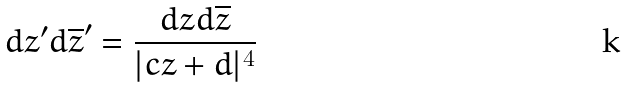<formula> <loc_0><loc_0><loc_500><loc_500>d z ^ { \prime } d \overline { z } ^ { \prime } = \frac { d z d \overline { z } } { | c z + d | ^ { 4 } }</formula> 